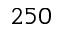Convert formula to latex. <formula><loc_0><loc_0><loc_500><loc_500>2 5 0</formula> 